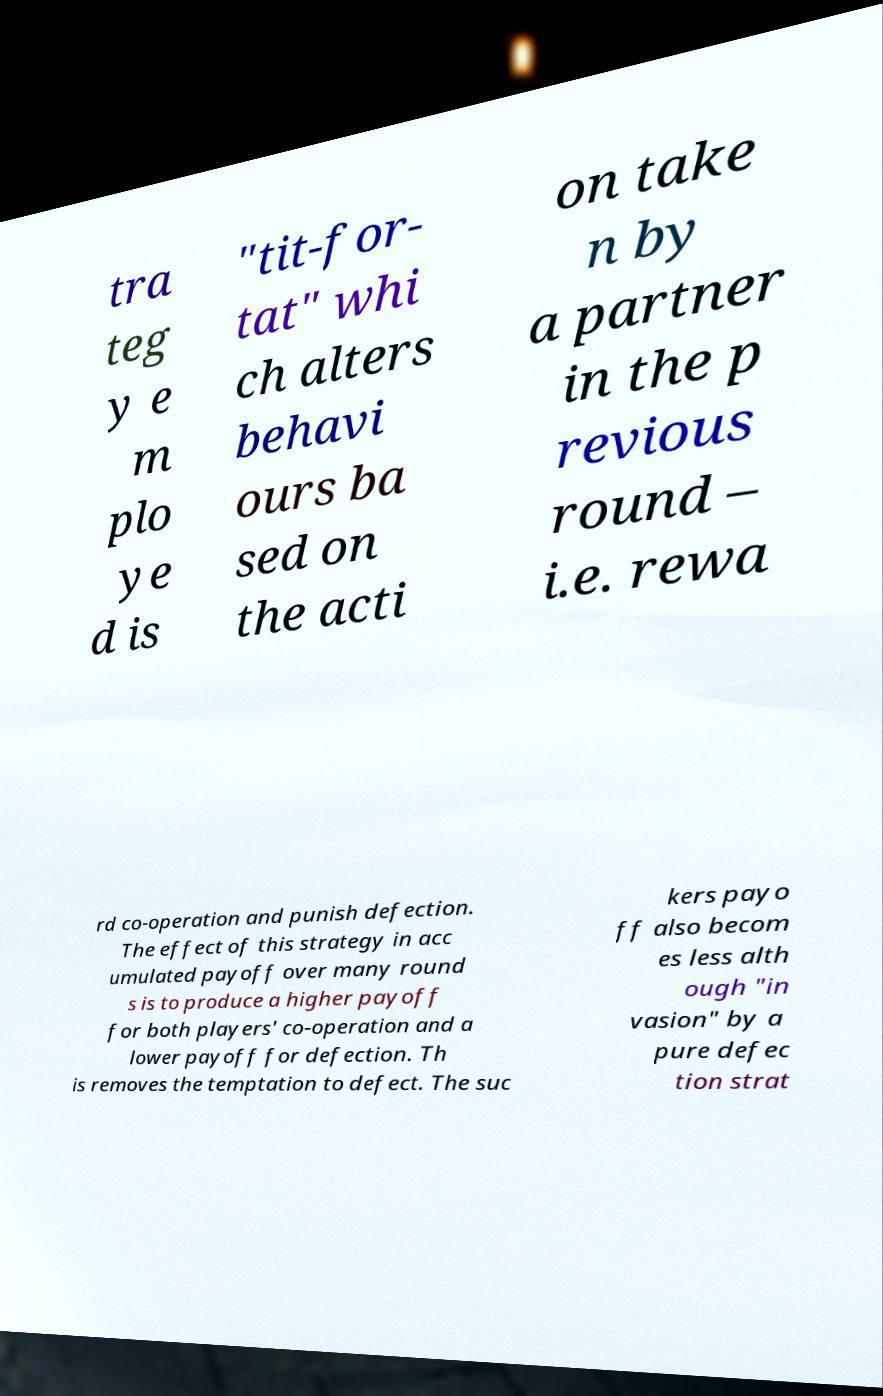I need the written content from this picture converted into text. Can you do that? tra teg y e m plo ye d is "tit-for- tat" whi ch alters behavi ours ba sed on the acti on take n by a partner in the p revious round – i.e. rewa rd co-operation and punish defection. The effect of this strategy in acc umulated payoff over many round s is to produce a higher payoff for both players' co-operation and a lower payoff for defection. Th is removes the temptation to defect. The suc kers payo ff also becom es less alth ough "in vasion" by a pure defec tion strat 